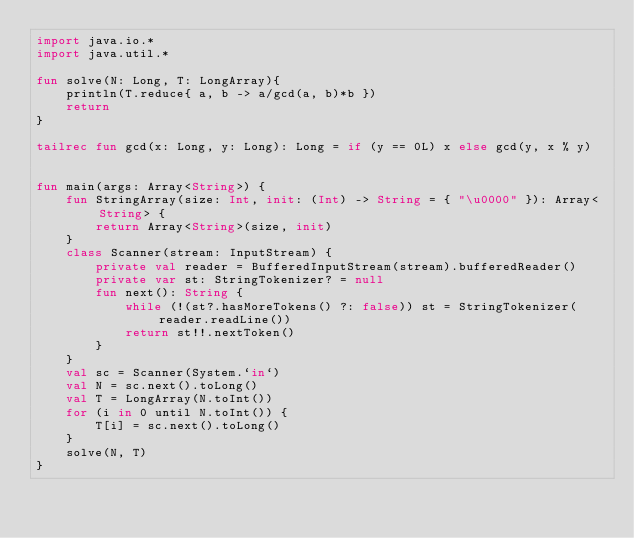Convert code to text. <code><loc_0><loc_0><loc_500><loc_500><_Kotlin_>import java.io.*
import java.util.*

fun solve(N: Long, T: LongArray){
    println(T.reduce{ a, b -> a/gcd(a, b)*b })
    return
}

tailrec fun gcd(x: Long, y: Long): Long = if (y == 0L) x else gcd(y, x % y)


fun main(args: Array<String>) {
    fun StringArray(size: Int, init: (Int) -> String = { "\u0000" }): Array<String> {
        return Array<String>(size, init)
    }
    class Scanner(stream: InputStream) {
        private val reader = BufferedInputStream(stream).bufferedReader()
        private var st: StringTokenizer? = null
        fun next(): String {
            while (!(st?.hasMoreTokens() ?: false)) st = StringTokenizer(reader.readLine())
            return st!!.nextToken()
        }
    }
    val sc = Scanner(System.`in`)
    val N = sc.next().toLong()
    val T = LongArray(N.toInt())
    for (i in 0 until N.toInt()) {
        T[i] = sc.next().toLong()
    }
    solve(N, T)
}

</code> 